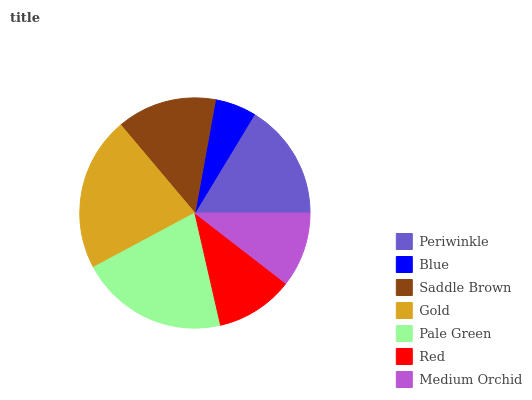Is Blue the minimum?
Answer yes or no. Yes. Is Gold the maximum?
Answer yes or no. Yes. Is Saddle Brown the minimum?
Answer yes or no. No. Is Saddle Brown the maximum?
Answer yes or no. No. Is Saddle Brown greater than Blue?
Answer yes or no. Yes. Is Blue less than Saddle Brown?
Answer yes or no. Yes. Is Blue greater than Saddle Brown?
Answer yes or no. No. Is Saddle Brown less than Blue?
Answer yes or no. No. Is Saddle Brown the high median?
Answer yes or no. Yes. Is Saddle Brown the low median?
Answer yes or no. Yes. Is Gold the high median?
Answer yes or no. No. Is Medium Orchid the low median?
Answer yes or no. No. 